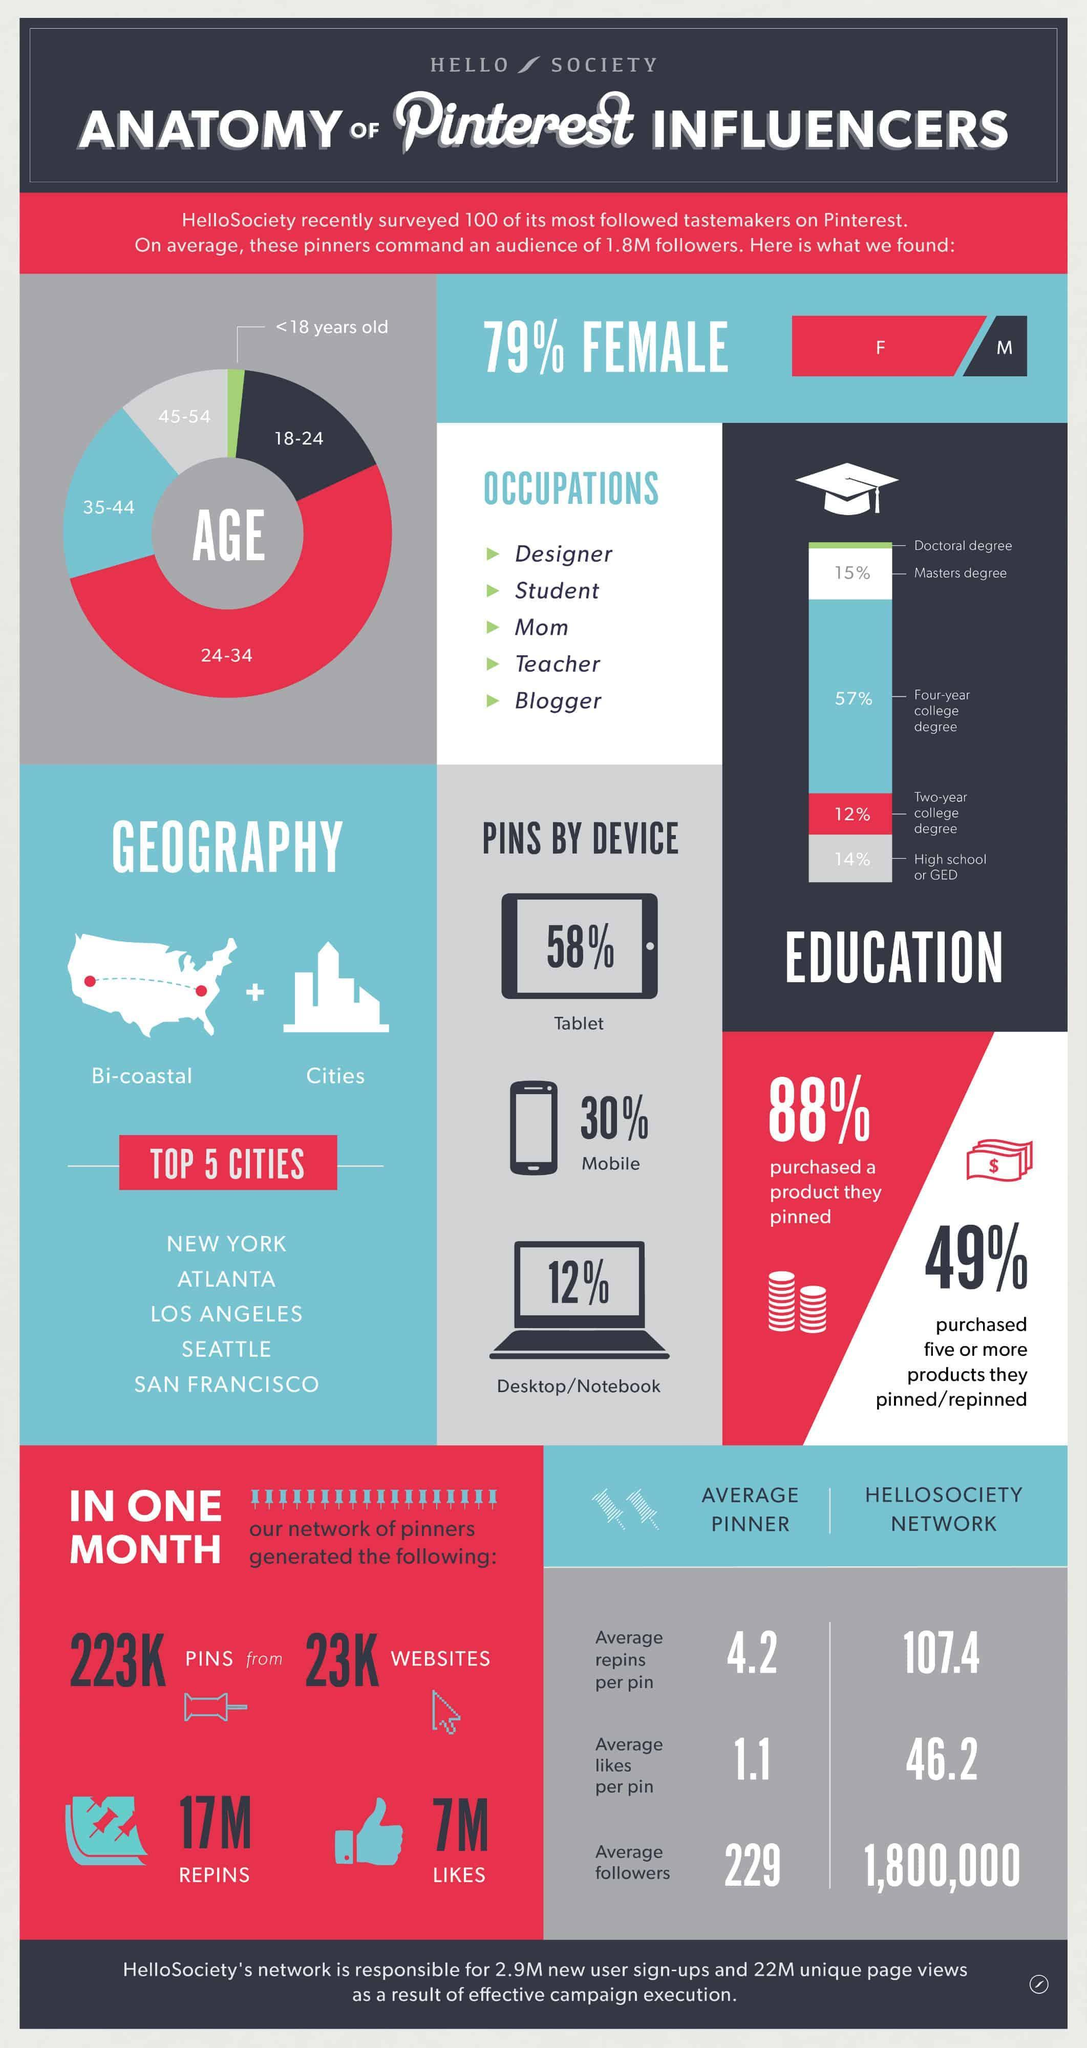What percentage of Pinners Pins through Desktop or Notebook?
Answer the question with a short phrase. 12% What percentage of people does not purchase five or more products they pinned or repinned? 51 Which age group has the second highest no of audience? 35-44 What percentage of Pinners are Male? 21 How many different types of Pinner Occupations are listed? 5 What percentage of people does not purchase product which they have pinned? 12 What percentage of Pinners Pins through Mobile? 30% 